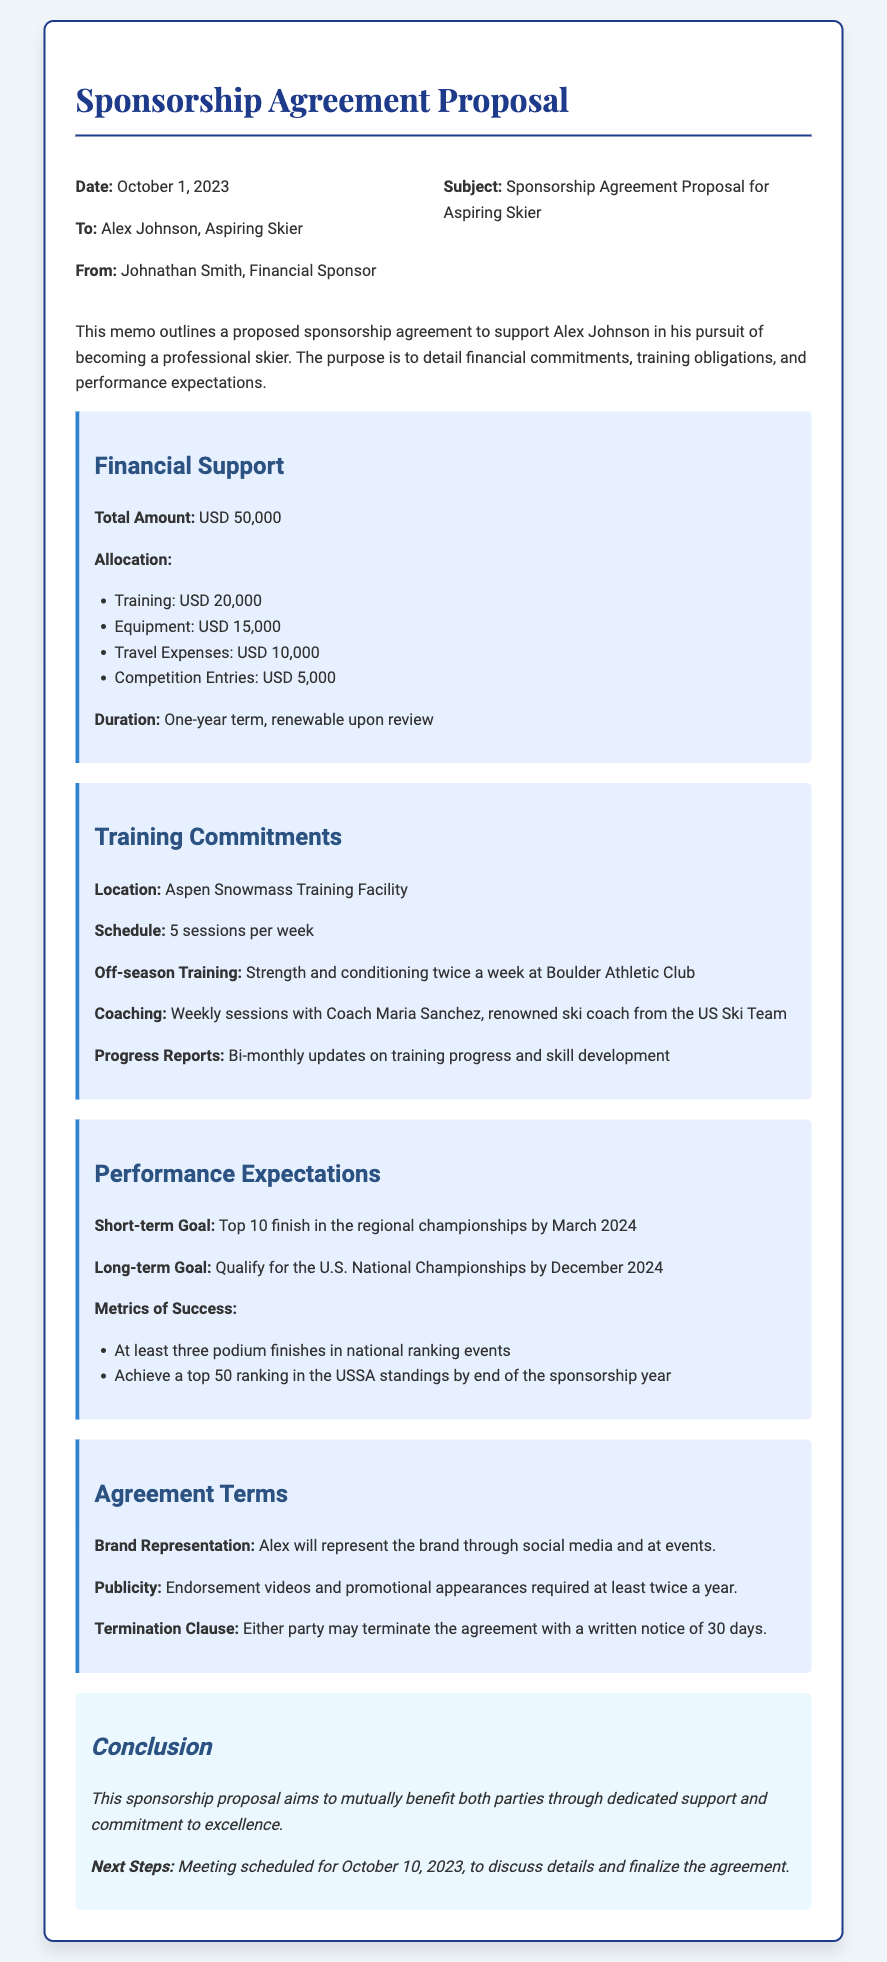what is the total amount of financial support? The total amount of financial support detailed in the document is specified as USD 50,000.
Answer: USD 50,000 who is the aspiring skier mentioned in the proposal? The memo addresses Alex Johnson as the aspiring skier receiving sponsorship.
Answer: Alex Johnson how many sessions per week are included in the training schedule? The training schedule stipulates 5 sessions per week for the aspiring skier.
Answer: 5 sessions what is the short-term goal mentioned in the performance expectations? The short-term goal outlined is a top 10 finish in the regional championships by a specific date.
Answer: Top 10 finish in the regional championships by March 2024 what is the name of the coaching facility mentioned for off-season training? The document references Boulder Athletic Club as the location for off-season training sessions.
Answer: Boulder Athletic Club how many podium finishes are required for the metrics of success? The metrics of success in the performance expectations state that at least three podium finishes are necessary.
Answer: At least three podium finishes what is the duration of the sponsorship agreement? The duration of the sponsorship agreement is specified as a one-year term.
Answer: One-year term how frequently are progress reports expected? The proposal outlines that bi-monthly progress reports on training and skill development are expected.
Answer: Bi-monthly what happens if either party wants to terminate the agreement? The termination clause states that either party may terminate the agreement with a written notice of 30 days.
Answer: Written notice of 30 days 